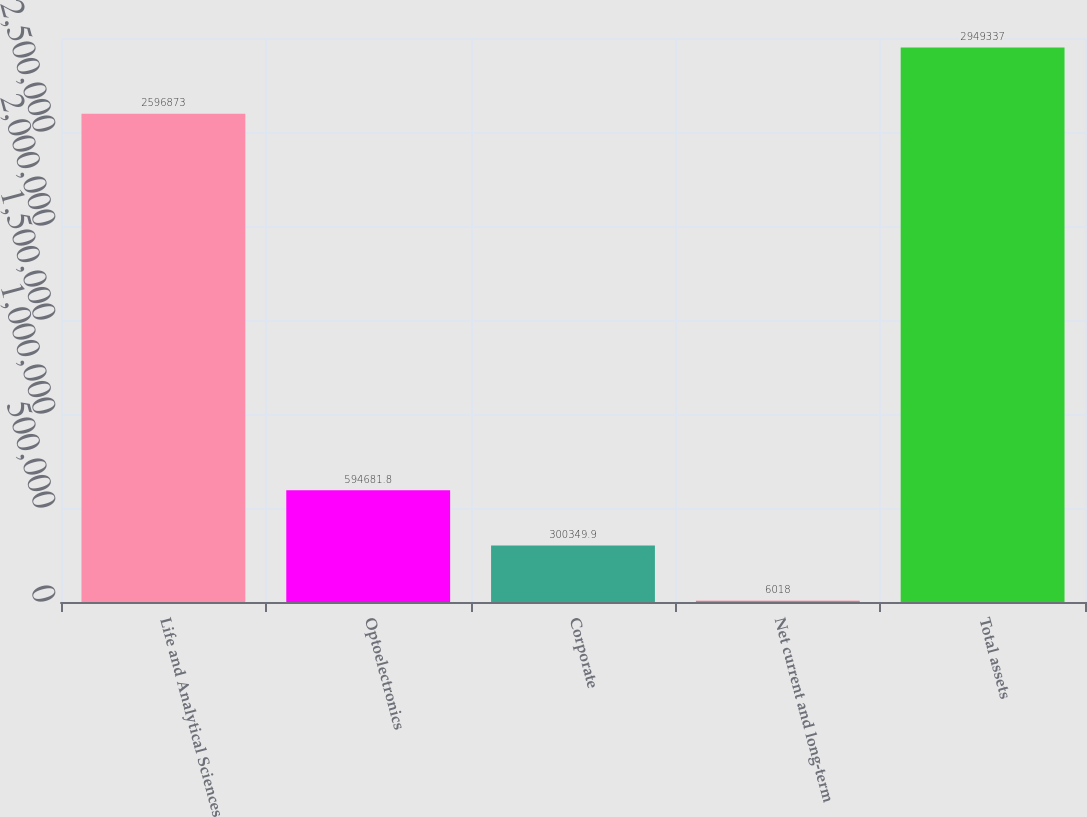<chart> <loc_0><loc_0><loc_500><loc_500><bar_chart><fcel>Life and Analytical Sciences<fcel>Optoelectronics<fcel>Corporate<fcel>Net current and long-term<fcel>Total assets<nl><fcel>2.59687e+06<fcel>594682<fcel>300350<fcel>6018<fcel>2.94934e+06<nl></chart> 